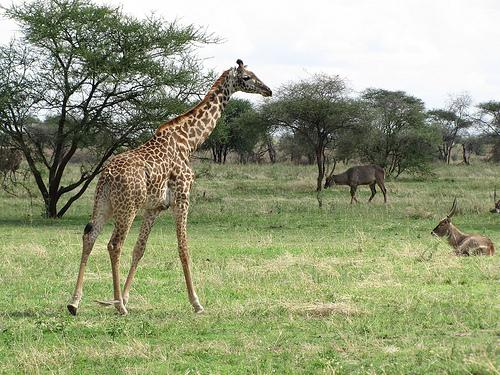What animal is dominating the scene and what is its general appearance? A brown spotted giraffe with a long neck, tan and brown patches, and white lower legs is the main subject, walking in a grassy area. Are there other animals present in the image? Describe their appearance and location. Yes, there is a light-colored sitting gazelle with large horns and a black nose, resting on the grass near some trees. Describe the color and state of the giraffe's tail, neck, and legs. The giraffe has a brown tail with black hair on its tip, a long neck with brown hair, and white bottoms on its brown and white legs. What are the key attributes of the giraffe's face in the image? The giraffe's face features a black eye, black nose, and a closed mouth. What type of landscape appears in the image, and describe its vegetation? A grassy plain with high green and yellow grass, accompanied by a blue sky filled with white clouds, creates the landscape. Assess the overall mood or sentiment conveyed by the image. The image conveys a peaceful and serene sentiment, depicting animals in a natural and untouched landscape. Identify the different types of vegetation in this image. The vegetation consists of short yellow and green grass, brown and green grassy field, and high grass. Form a complex reasoning question based on the information available in the image. Do the presence of different types of grass and the diverse set of animals suggest that this location may be part of a natural reserve or a protected wildlife area? How many individual clouds are visible in the sky? Five distinct white clouds can be seen in the blue sky. What is the position of the gazelle with respect to the giraffe? The gazelle is sitting towards the right side and slightly behind the giraffe in the grassy plain. 